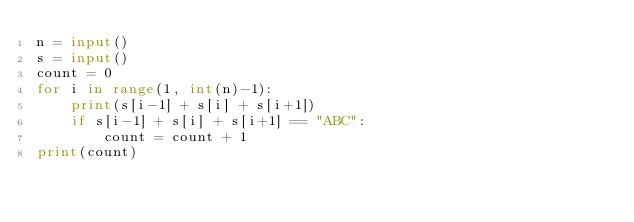Convert code to text. <code><loc_0><loc_0><loc_500><loc_500><_Python_>n = input()
s = input()
count = 0
for i in range(1, int(n)-1):
    print(s[i-1] + s[i] + s[i+1])
    if s[i-1] + s[i] + s[i+1] == "ABC":
        count = count + 1
print(count)</code> 